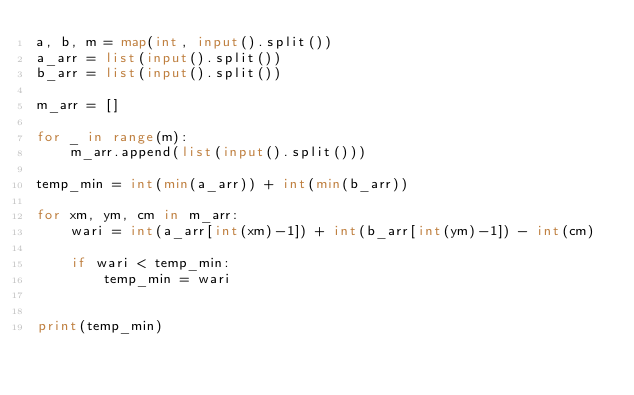Convert code to text. <code><loc_0><loc_0><loc_500><loc_500><_Python_>a, b, m = map(int, input().split())
a_arr = list(input().split())
b_arr = list(input().split())

m_arr = []

for _ in range(m):
    m_arr.append(list(input().split()))

temp_min = int(min(a_arr)) + int(min(b_arr))

for xm, ym, cm in m_arr:
    wari = int(a_arr[int(xm)-1]) + int(b_arr[int(ym)-1]) - int(cm)

    if wari < temp_min:
        temp_min = wari


print(temp_min)
</code> 